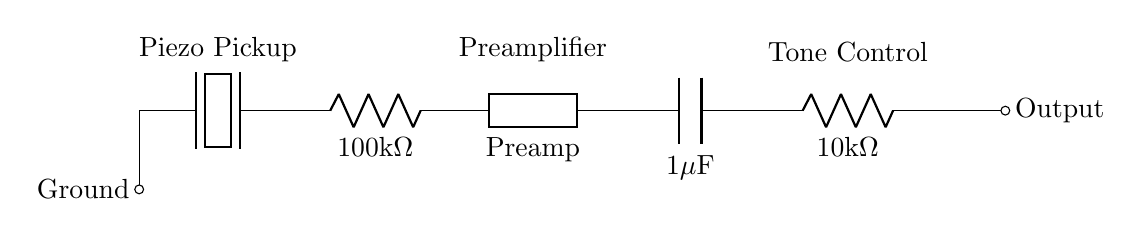What is the component labeled as R1? R1 is labeled as a resistor with a value of one hundred kilohms in the circuit. This is indicated by the label next to the resistor symbol.
Answer: one hundred kilohms What does the piezoelectric component do? The piezoelectric component converts mechanical vibration from guitar strings into an electrical signal. This is inferred from its position as the first element in the circuit.
Answer: converts vibrations What is the value of C1 in the circuit? The capacitor C1 is labeled as having a value of one microfarad. This is indicated by the label next to the capacitor symbol in the diagram.
Answer: one microfarad How many resistors are present in the circuit? There are two resistors shown in the circuit: R1 and R2, which are visible in the series connection.
Answer: two What is the role of the preamp in this circuit? The preamp amplifies the output signal from the piezo electric pickup before it reaches the tone control. This function is based on its position in the circuit, following the pickup.
Answer: amplifies signal What happens to the output signal after R2? The output signal after R2 is sent to the tone control and then exits the circuit, indicated by the "Output" label associated with the line after R2.
Answer: sent to tone control What type of circuit is this? This is a series circuit, as all components are connected end-to-end, forming a single path for current flow. This can be observed from the layout of the components.
Answer: series circuit 